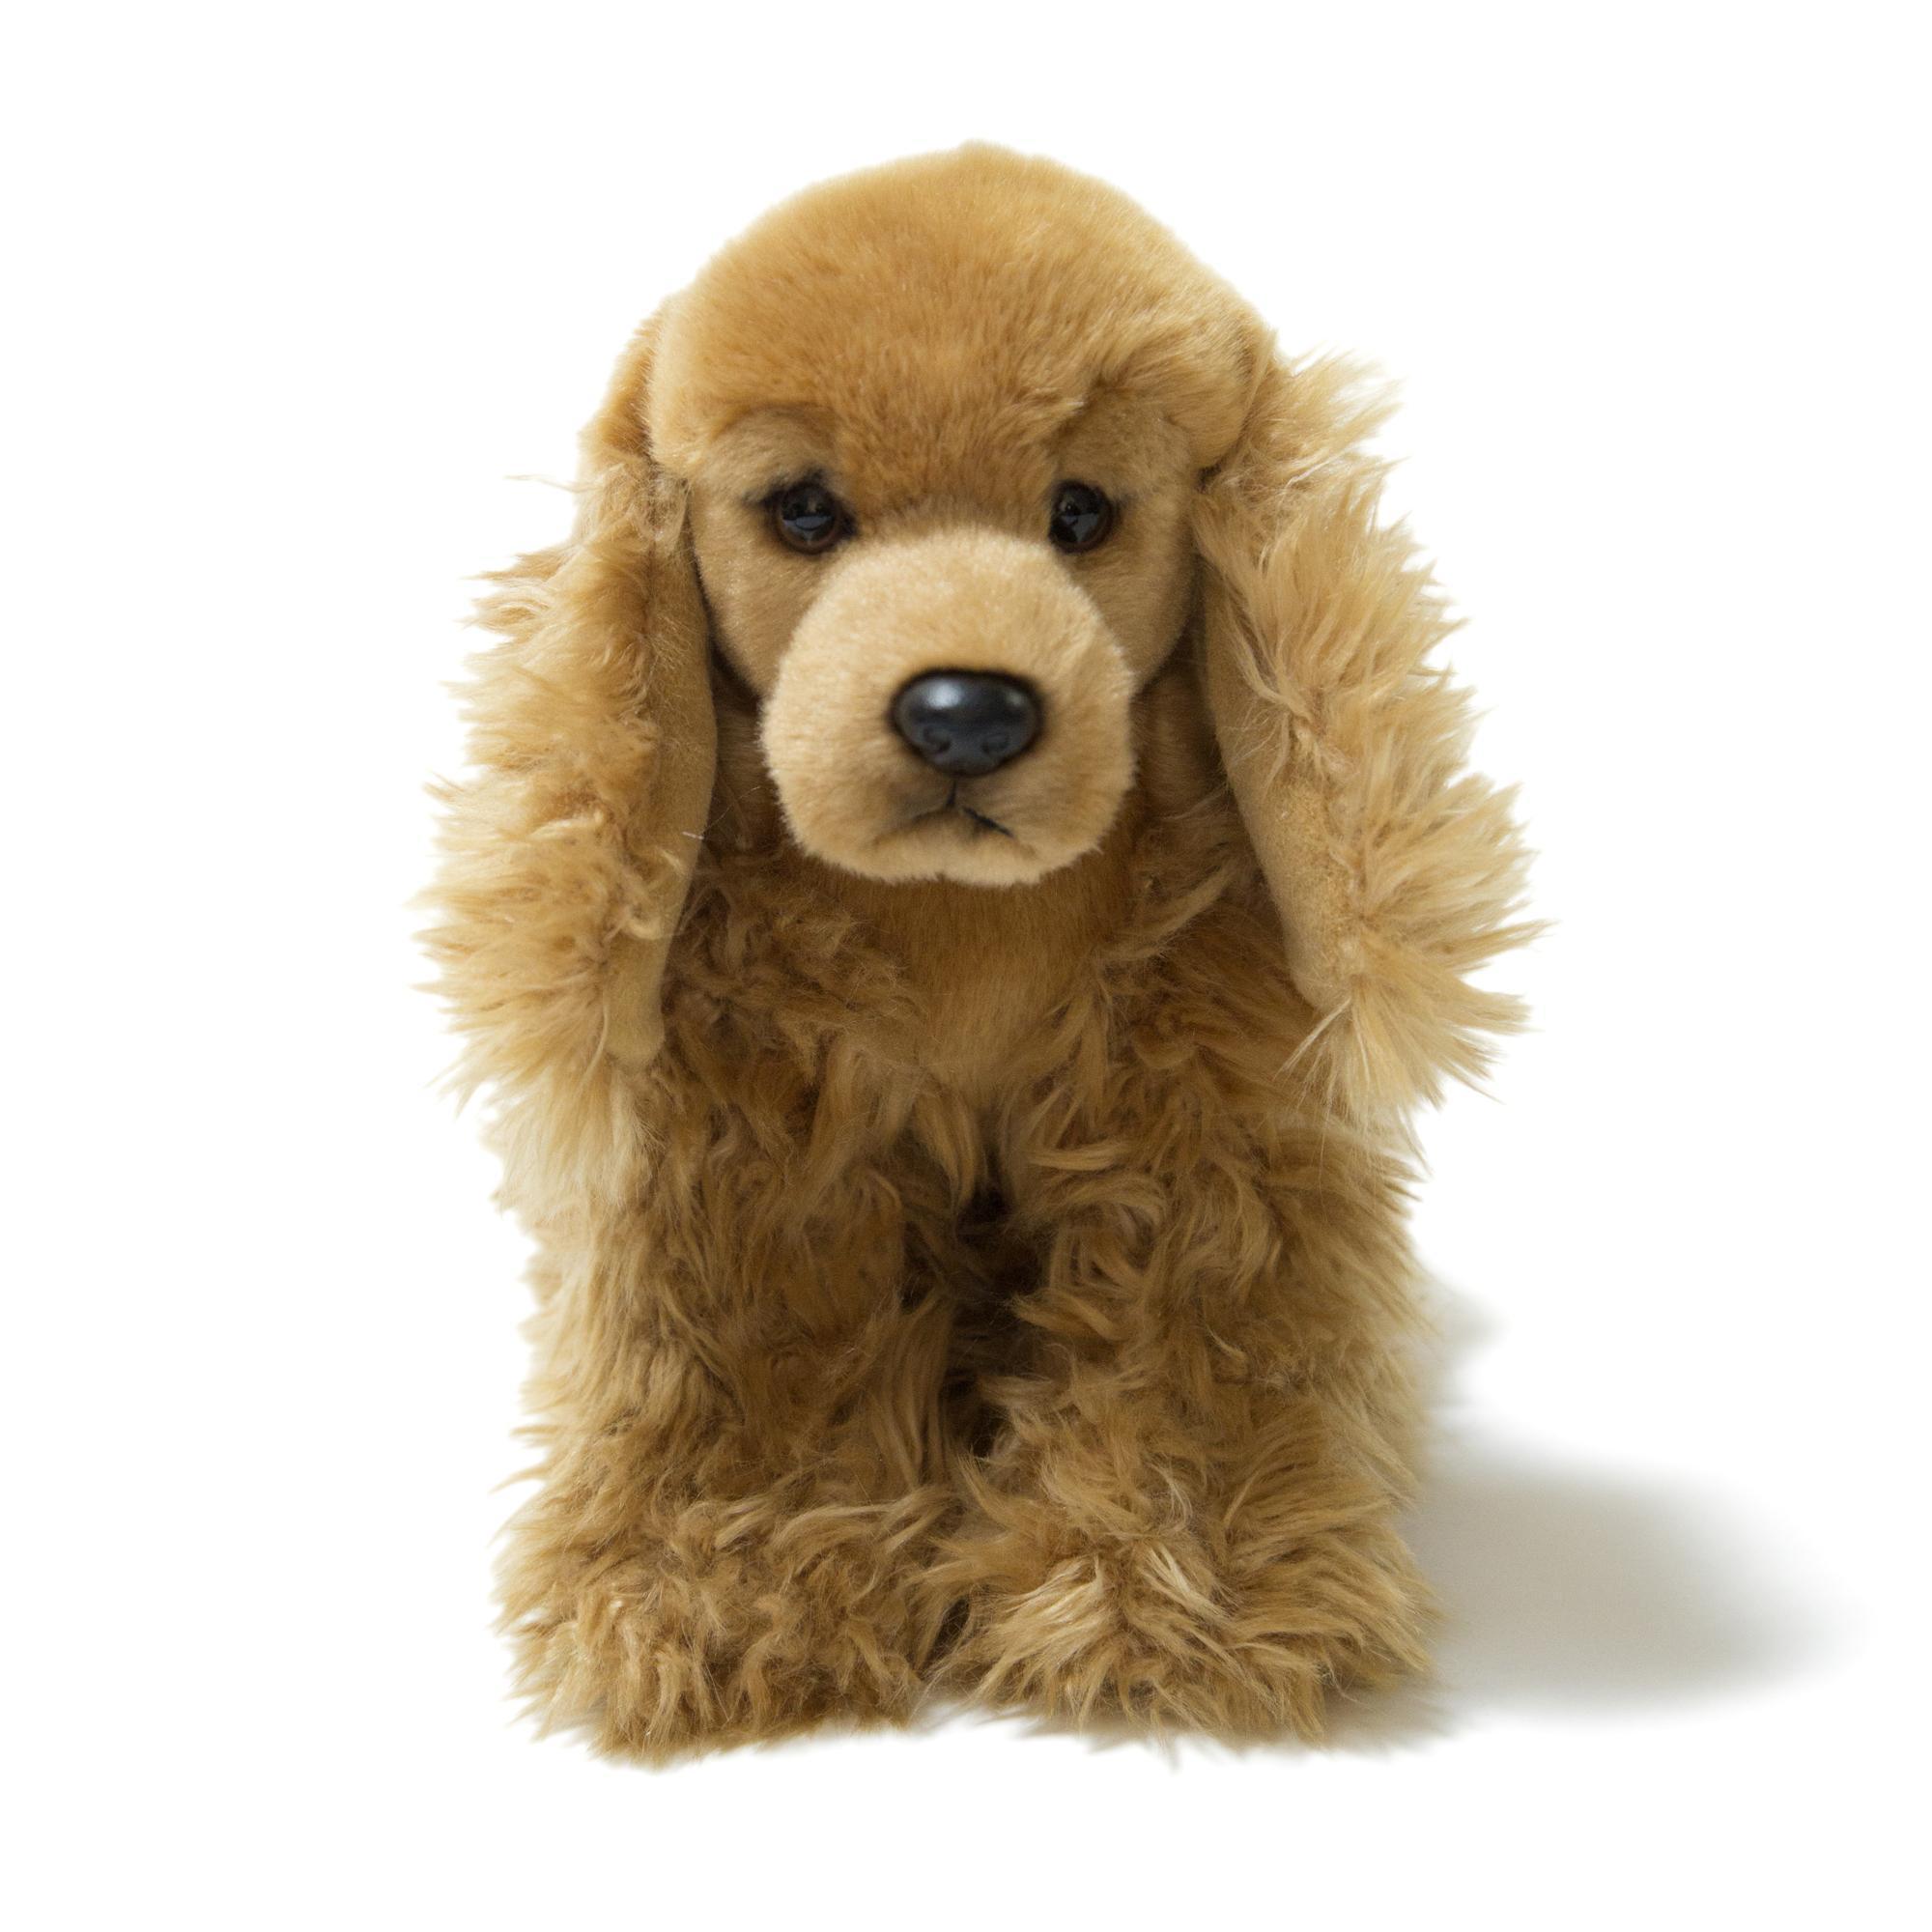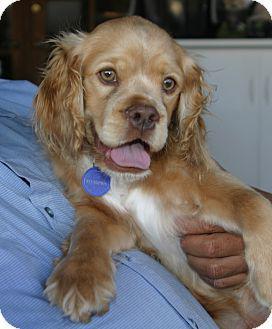The first image is the image on the left, the second image is the image on the right. For the images displayed, is the sentence "There are two dogs in the left image." factually correct? Answer yes or no. No. The first image is the image on the left, the second image is the image on the right. Assess this claim about the two images: "There is a young tan puppy on top of a curlyhaired brown puppy.". Correct or not? Answer yes or no. No. 